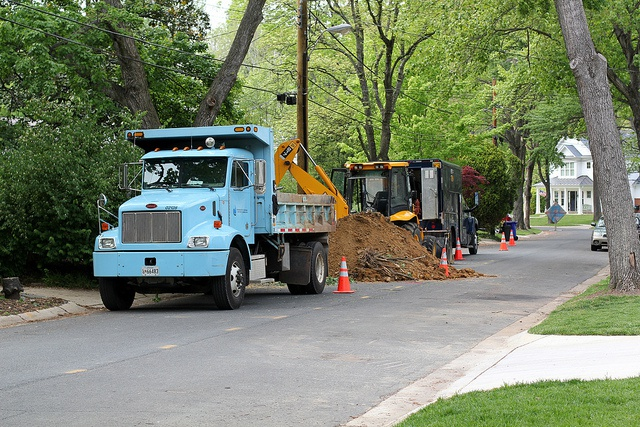Describe the objects in this image and their specific colors. I can see truck in olive, black, lightblue, and gray tones, truck in olive, black, gray, and darkgray tones, and car in olive, gray, darkgray, black, and lightgray tones in this image. 